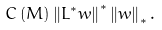Convert formula to latex. <formula><loc_0><loc_0><loc_500><loc_500>C \left ( M \right ) \left \| L ^ { \ast } w \right \| ^ { \ast } \left \| w \right \| _ { \ast } .</formula> 